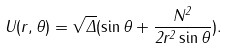<formula> <loc_0><loc_0><loc_500><loc_500>U ( r , \theta ) = \sqrt { \Delta } ( \sin \theta + \frac { N ^ { 2 } } { 2 r ^ { 2 } \sin \theta } ) .</formula> 